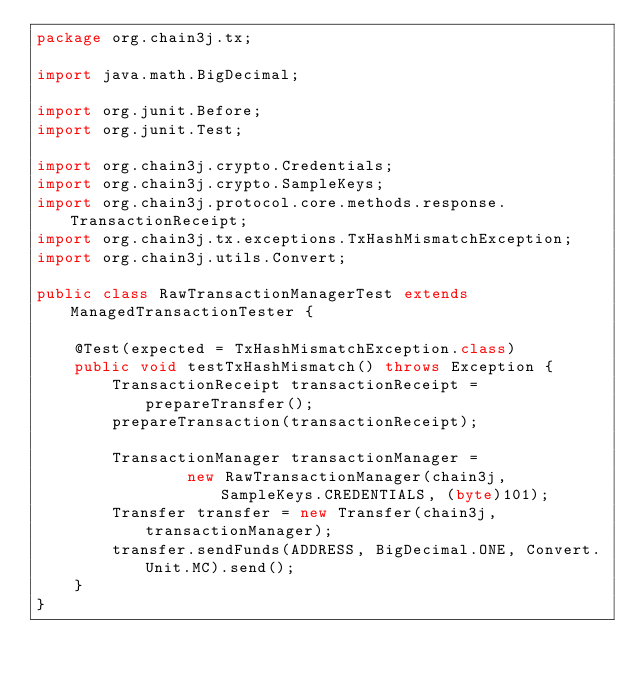<code> <loc_0><loc_0><loc_500><loc_500><_Java_>package org.chain3j.tx;

import java.math.BigDecimal;

import org.junit.Before;
import org.junit.Test;

import org.chain3j.crypto.Credentials;
import org.chain3j.crypto.SampleKeys;
import org.chain3j.protocol.core.methods.response.TransactionReceipt;
import org.chain3j.tx.exceptions.TxHashMismatchException;
import org.chain3j.utils.Convert;

public class RawTransactionManagerTest extends ManagedTransactionTester {

    @Test(expected = TxHashMismatchException.class)
    public void testTxHashMismatch() throws Exception {
        TransactionReceipt transactionReceipt = prepareTransfer();
        prepareTransaction(transactionReceipt);

        TransactionManager transactionManager =
                new RawTransactionManager(chain3j, SampleKeys.CREDENTIALS, (byte)101);
        Transfer transfer = new Transfer(chain3j, transactionManager);
        transfer.sendFunds(ADDRESS, BigDecimal.ONE, Convert.Unit.MC).send();
    }
}
</code> 